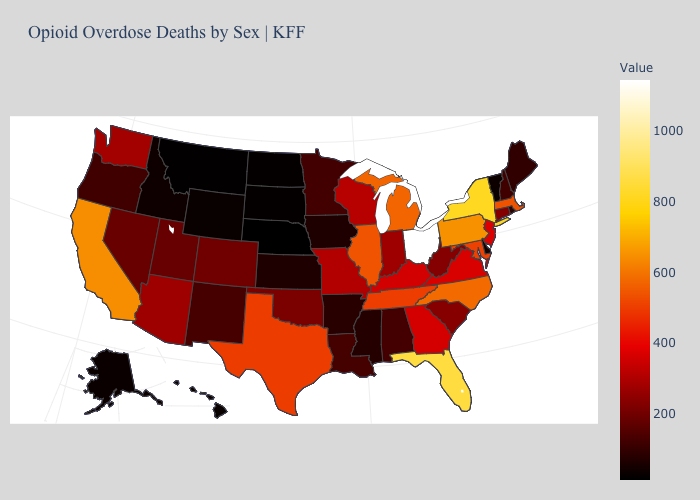Does Maryland have a lower value than New York?
Write a very short answer. Yes. Which states have the lowest value in the USA?
Answer briefly. Nebraska. Among the states that border Illinois , which have the highest value?
Short answer required. Kentucky. Among the states that border Vermont , which have the highest value?
Answer briefly. New York. Among the states that border Texas , which have the lowest value?
Be succinct. Arkansas. 